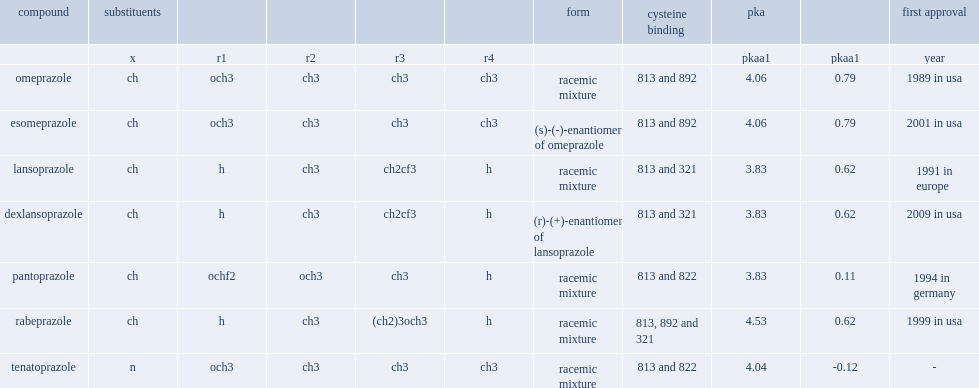What is the number of rabeprazole bind to cysteine? 813, 892 and 321. 